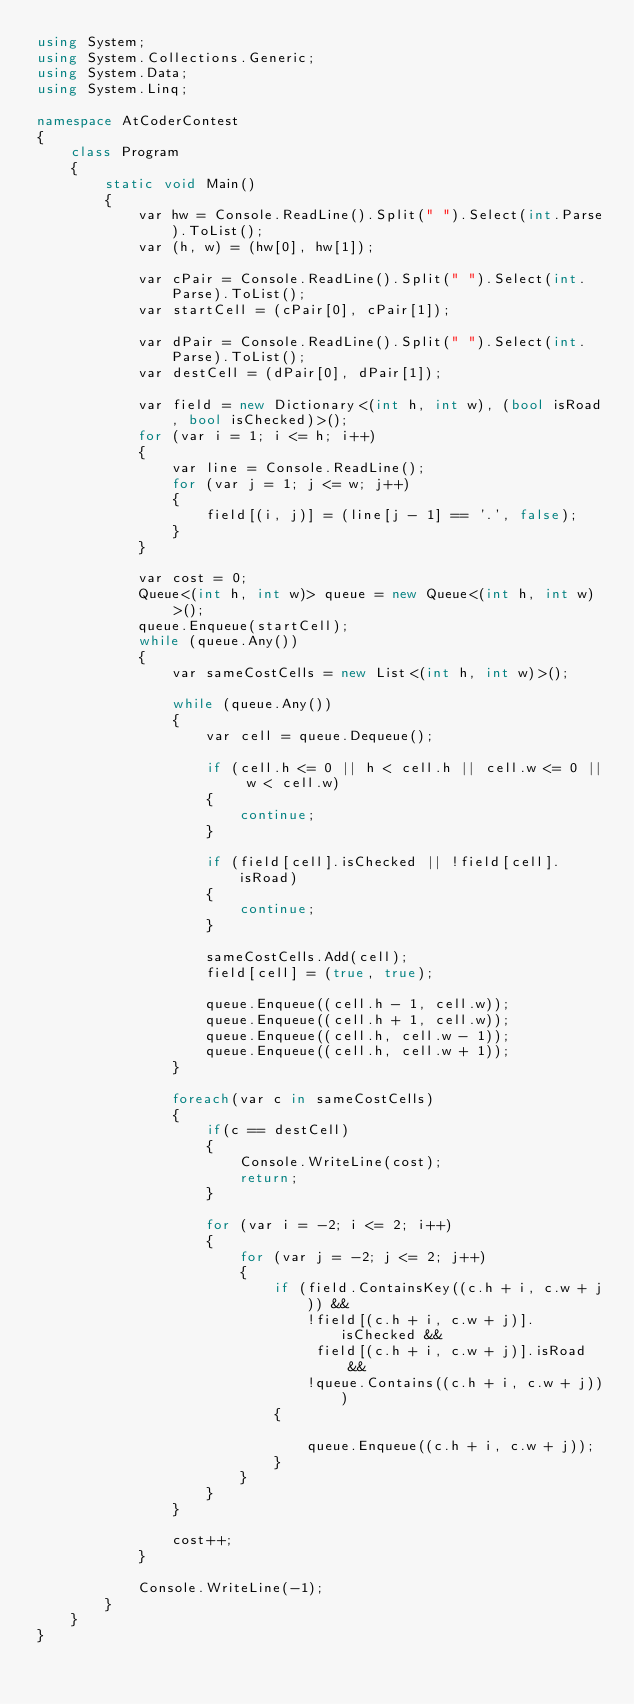Convert code to text. <code><loc_0><loc_0><loc_500><loc_500><_C#_>using System;
using System.Collections.Generic;
using System.Data;
using System.Linq;

namespace AtCoderContest
{
    class Program
    {
        static void Main()
        {
            var hw = Console.ReadLine().Split(" ").Select(int.Parse).ToList();
            var (h, w) = (hw[0], hw[1]);

            var cPair = Console.ReadLine().Split(" ").Select(int.Parse).ToList();
            var startCell = (cPair[0], cPair[1]);

            var dPair = Console.ReadLine().Split(" ").Select(int.Parse).ToList();
            var destCell = (dPair[0], dPair[1]);

            var field = new Dictionary<(int h, int w), (bool isRoad, bool isChecked)>();
            for (var i = 1; i <= h; i++)
            {
                var line = Console.ReadLine();
                for (var j = 1; j <= w; j++)
                {
                    field[(i, j)] = (line[j - 1] == '.', false);
                }
            }

            var cost = 0;
            Queue<(int h, int w)> queue = new Queue<(int h, int w)>();
            queue.Enqueue(startCell);
            while (queue.Any())
            {
                var sameCostCells = new List<(int h, int w)>();

                while (queue.Any())
                {
                    var cell = queue.Dequeue();

                    if (cell.h <= 0 || h < cell.h || cell.w <= 0 || w < cell.w)
                    {
                        continue;
                    }

                    if (field[cell].isChecked || !field[cell].isRoad)
                    {
                        continue;
                    }

                    sameCostCells.Add(cell);
                    field[cell] = (true, true);

                    queue.Enqueue((cell.h - 1, cell.w));
                    queue.Enqueue((cell.h + 1, cell.w));
                    queue.Enqueue((cell.h, cell.w - 1));
                    queue.Enqueue((cell.h, cell.w + 1));
                }

                foreach(var c in sameCostCells)
                {
                    if(c == destCell)
                    {
                        Console.WriteLine(cost);
                        return;
                    }

                    for (var i = -2; i <= 2; i++)
                    {
                        for (var j = -2; j <= 2; j++)
                        {
                            if (field.ContainsKey((c.h + i, c.w + j)) &&
                                !field[(c.h + i, c.w + j)].isChecked &&
                                 field[(c.h + i, c.w + j)].isRoad &&
                                !queue.Contains((c.h + i, c.w + j)))
                            {
                                
                                queue.Enqueue((c.h + i, c.w + j));
                            }
                        }
                    }
                }

                cost++;
            }

            Console.WriteLine(-1);
        }
    }
}
</code> 